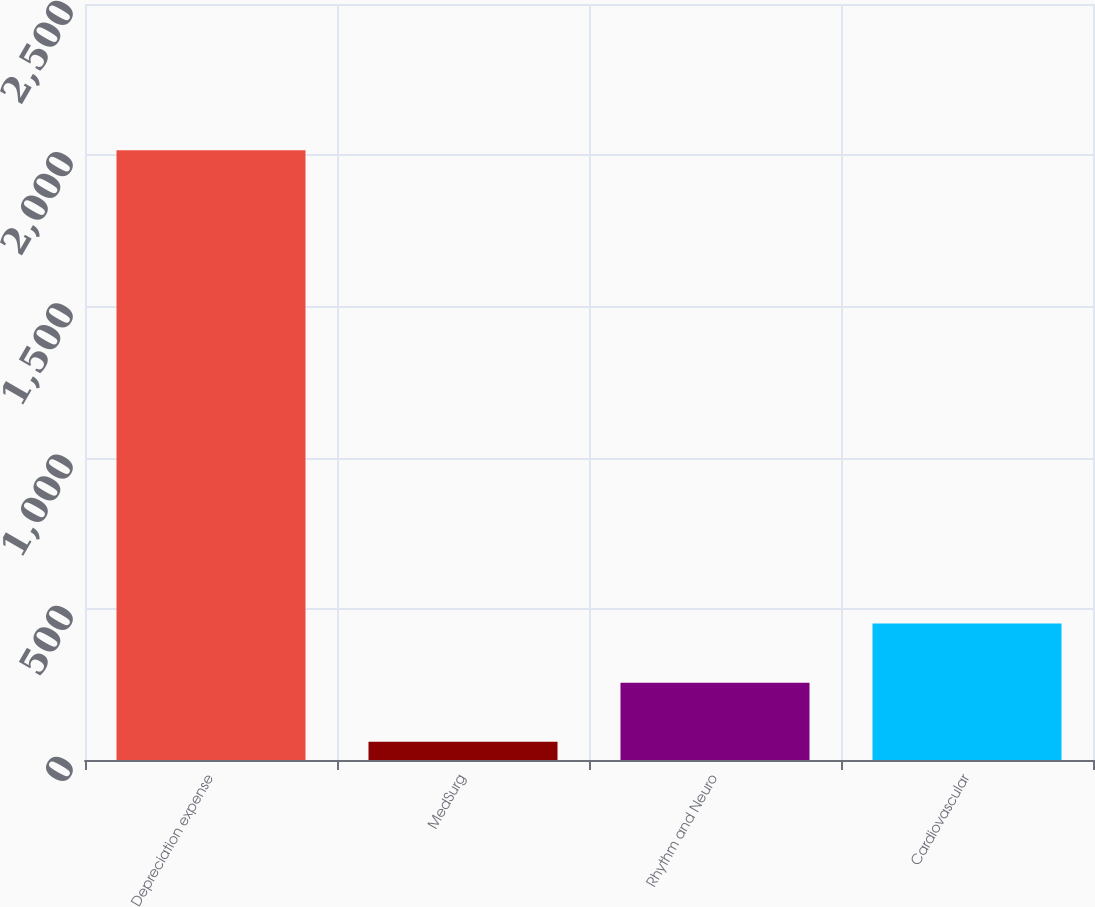<chart> <loc_0><loc_0><loc_500><loc_500><bar_chart><fcel>Depreciation expense<fcel>MedSurg<fcel>Rhythm and Neuro<fcel>Cardiovascular<nl><fcel>2016<fcel>60<fcel>255.6<fcel>451.2<nl></chart> 